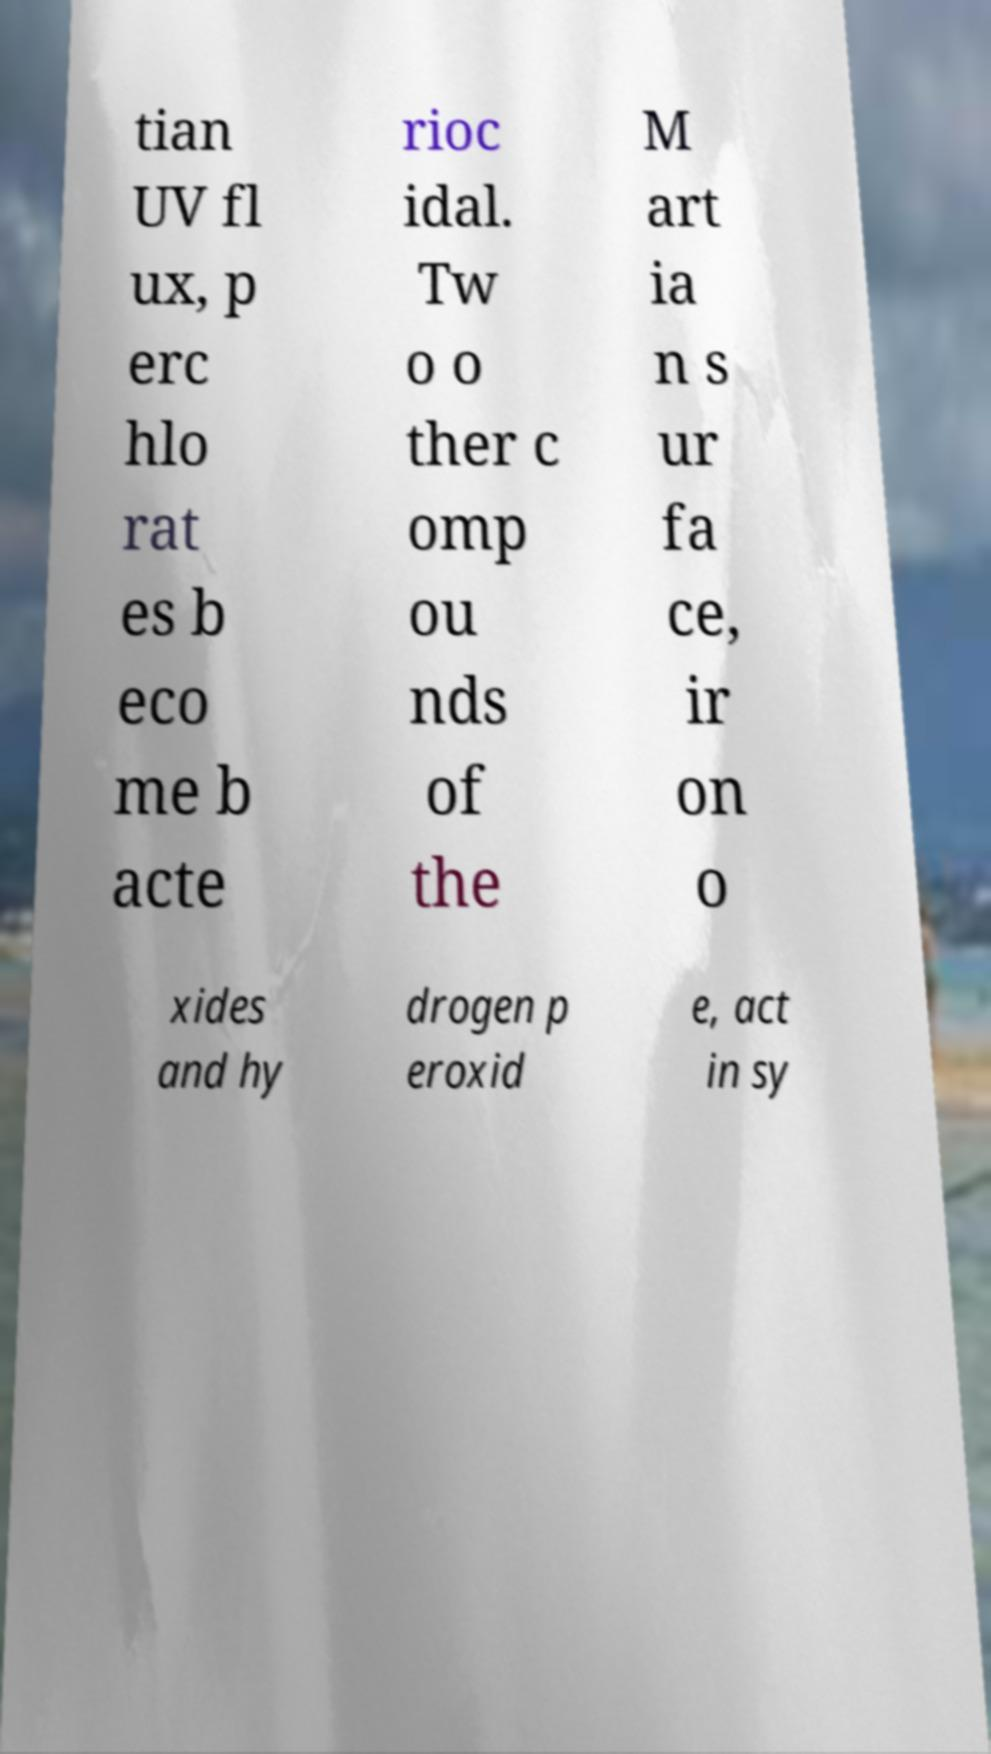Please read and relay the text visible in this image. What does it say? tian UV fl ux, p erc hlo rat es b eco me b acte rioc idal. Tw o o ther c omp ou nds of the M art ia n s ur fa ce, ir on o xides and hy drogen p eroxid e, act in sy 